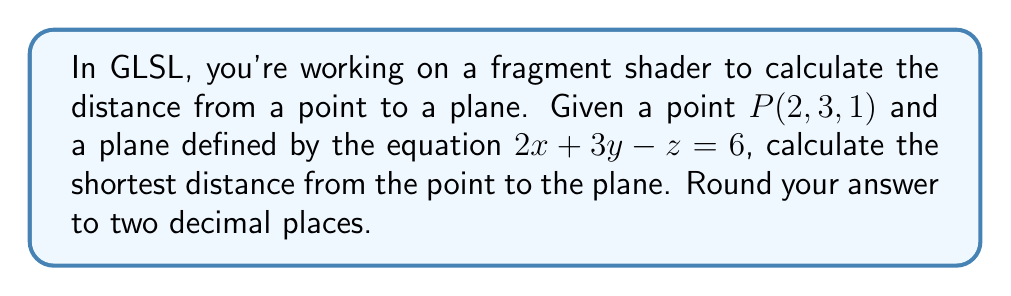What is the answer to this math problem? To solve this problem, we'll use the formula for the distance from a point to a plane in 3D space. This is relevant to GLSL as it can be used in various graphics effects and calculations.

The general equation of a plane is $Ax + By + Cz + D = 0$. In our case:

$2x + 3y - z - 6 = 0$

So, $A = 2$, $B = 3$, $C = -1$, and $D = -6$.

The formula for the distance $d$ from a point $(x_0, y_0, z_0)$ to a plane $Ax + By + Cz + D = 0$ is:

$$ d = \frac{|Ax_0 + By_0 + Cz_0 + D|}{\sqrt{A^2 + B^2 + C^2}} $$

Let's plug in our values:

$x_0 = 2$, $y_0 = 3$, $z_0 = 1$

$$ d = \frac{|2(2) + 3(3) + (-1)(1) + (-6)|}{\sqrt{2^2 + 3^2 + (-1)^2}} $$

$$ d = \frac{|4 + 9 - 1 - 6|}{\sqrt{4 + 9 + 1}} $$

$$ d = \frac{|6|}{\sqrt{14}} $$

$$ d = \frac{6}{\sqrt{14}} $$

$$ d \approx 1.60 $$

Rounded to two decimal places, the distance is 1.60 units.
Answer: 1.60 units 